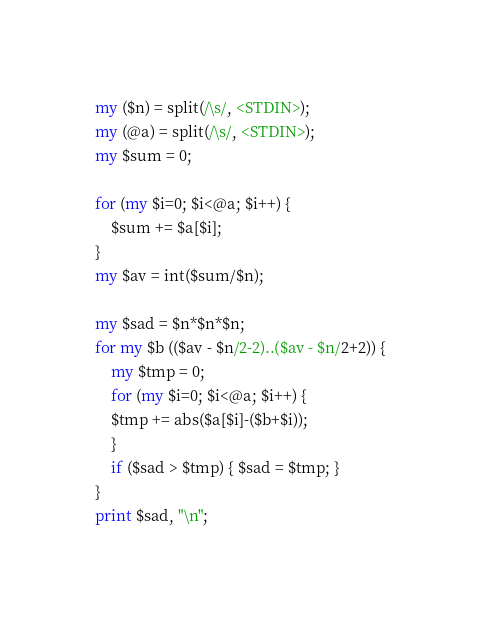<code> <loc_0><loc_0><loc_500><loc_500><_Perl_>my ($n) = split(/\s/, <STDIN>);
my (@a) = split(/\s/, <STDIN>);
my $sum = 0;

for (my $i=0; $i<@a; $i++) {
    $sum += $a[$i];
}
my $av = int($sum/$n);

my $sad = $n*$n*$n;
for my $b (($av - $n/2-2)..($av - $n/2+2)) {
    my $tmp = 0;
    for (my $i=0; $i<@a; $i++) {
	$tmp += abs($a[$i]-($b+$i));
    }
    if ($sad > $tmp) { $sad = $tmp; }
}
print $sad, "\n";
</code> 